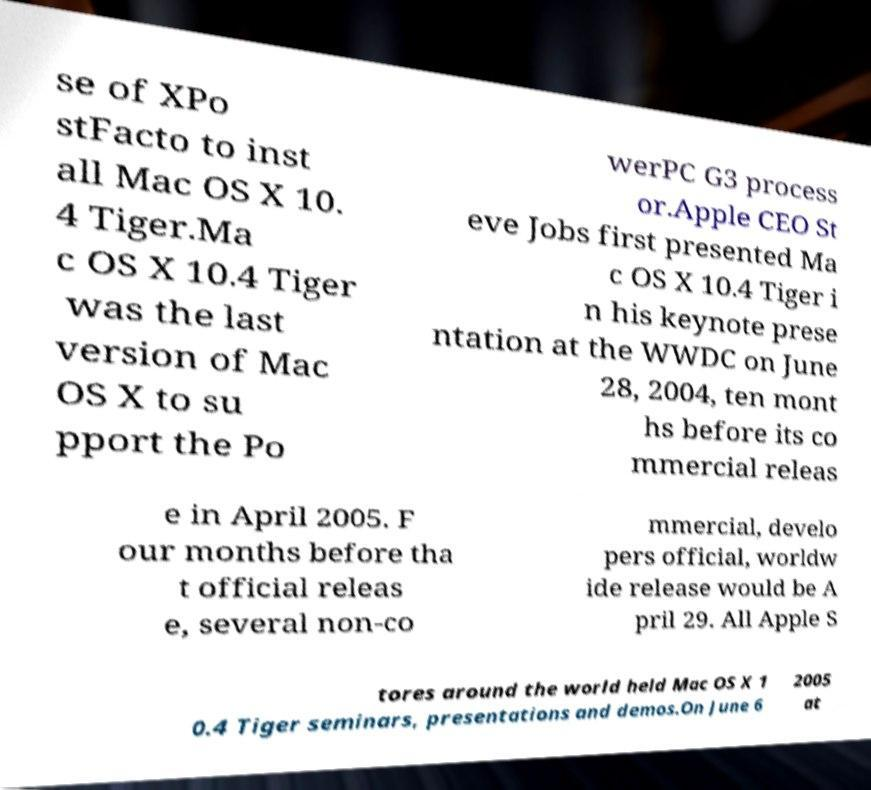What messages or text are displayed in this image? I need them in a readable, typed format. se of XPo stFacto to inst all Mac OS X 10. 4 Tiger.Ma c OS X 10.4 Tiger was the last version of Mac OS X to su pport the Po werPC G3 process or.Apple CEO St eve Jobs first presented Ma c OS X 10.4 Tiger i n his keynote prese ntation at the WWDC on June 28, 2004, ten mont hs before its co mmercial releas e in April 2005. F our months before tha t official releas e, several non-co mmercial, develo pers official, worldw ide release would be A pril 29. All Apple S tores around the world held Mac OS X 1 0.4 Tiger seminars, presentations and demos.On June 6 2005 at 